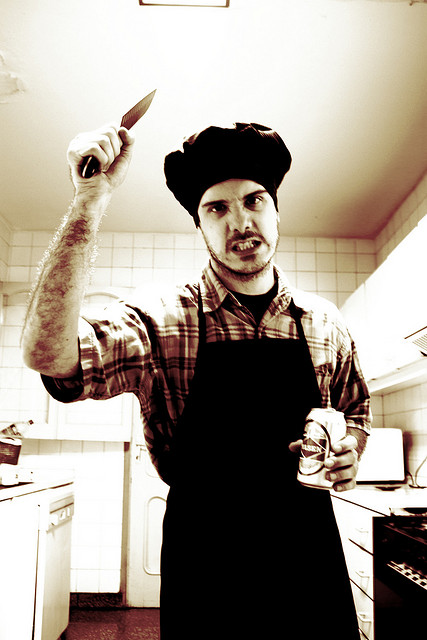<image>What is the artwork on the man's arm? It is ambiguous what the artwork on the man's arm is. It could be a tattoo or something else. What is the artwork on the man's arm? It is unclear what artwork is on the man's arm. It can be seen as a tattoo or nothing. 